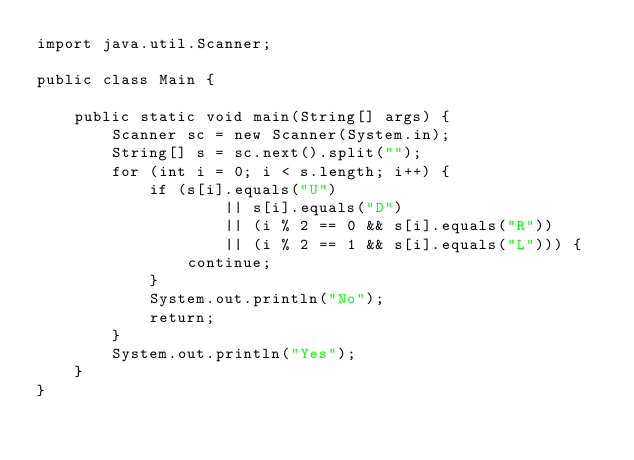<code> <loc_0><loc_0><loc_500><loc_500><_Java_>import java.util.Scanner;

public class Main {

    public static void main(String[] args) {
        Scanner sc = new Scanner(System.in);
        String[] s = sc.next().split("");
        for (int i = 0; i < s.length; i++) {
            if (s[i].equals("U")
                    || s[i].equals("D")
                    || (i % 2 == 0 && s[i].equals("R"))
                    || (i % 2 == 1 && s[i].equals("L"))) {
                continue;
            }
            System.out.println("No");
            return;
        }
        System.out.println("Yes");
    }
}

</code> 